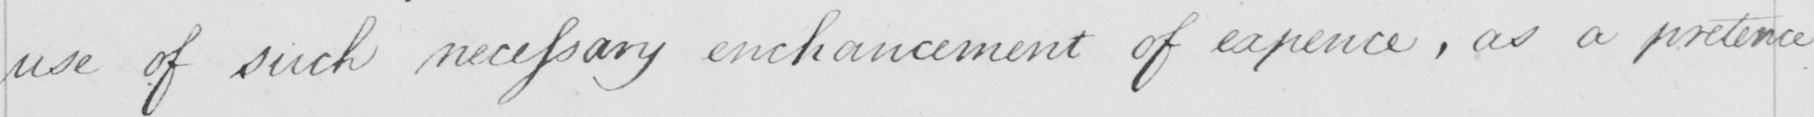Please transcribe the handwritten text in this image. use of such necessary enhancement of expence , as a pretence 